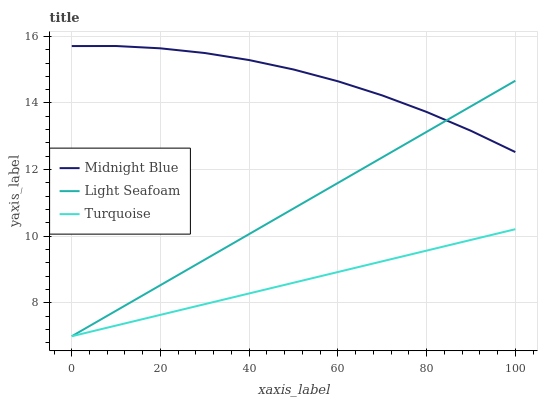Does Turquoise have the minimum area under the curve?
Answer yes or no. Yes. Does Midnight Blue have the maximum area under the curve?
Answer yes or no. Yes. Does Light Seafoam have the minimum area under the curve?
Answer yes or no. No. Does Light Seafoam have the maximum area under the curve?
Answer yes or no. No. Is Light Seafoam the smoothest?
Answer yes or no. Yes. Is Midnight Blue the roughest?
Answer yes or no. Yes. Is Midnight Blue the smoothest?
Answer yes or no. No. Is Light Seafoam the roughest?
Answer yes or no. No. Does Midnight Blue have the lowest value?
Answer yes or no. No. Does Light Seafoam have the highest value?
Answer yes or no. No. Is Turquoise less than Midnight Blue?
Answer yes or no. Yes. Is Midnight Blue greater than Turquoise?
Answer yes or no. Yes. Does Turquoise intersect Midnight Blue?
Answer yes or no. No. 